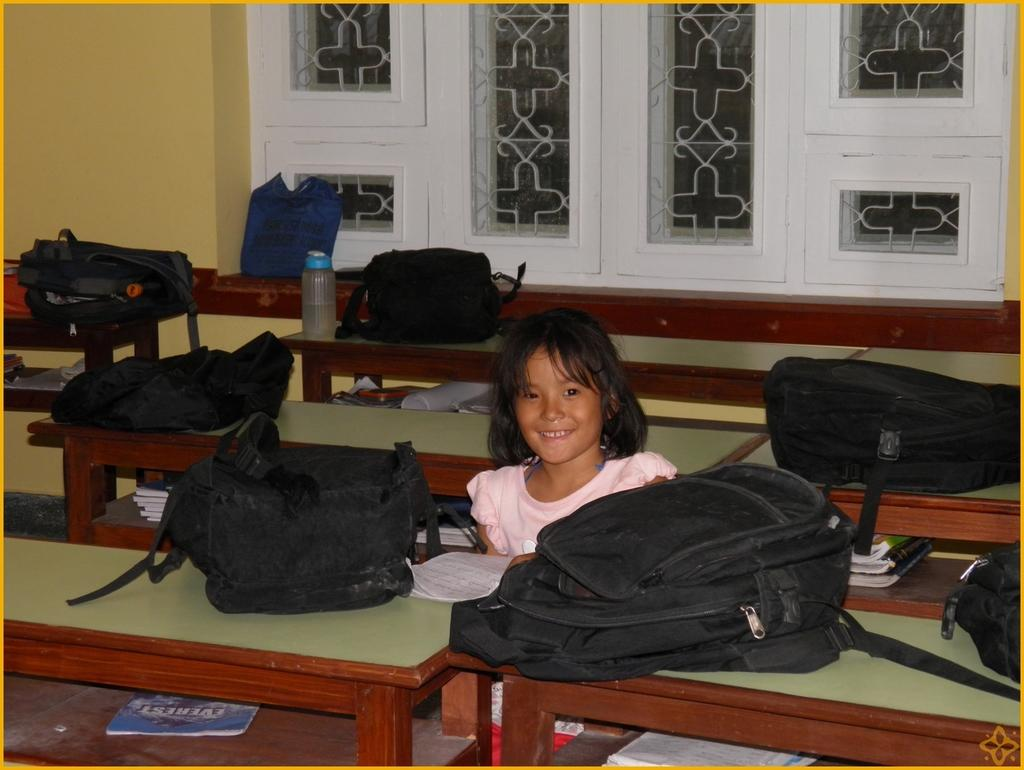What is the girl doing in the image? The girl is sitting on a bench in the image. What is in front of the girl? There is a table in front of the girl. What items can be seen on the table? There are bags placed on the table, and books are placed under the bags. Is there any other object present in the image? Yes, there is a bottle present in the image. What type of lunch is the monkey eating in the image? There is no monkey present in the image, and therefore no lunch can be observed. What is the girl's interest in the image? The provided facts do not mention the girl's interest, so we cannot determine her interest from the image. 